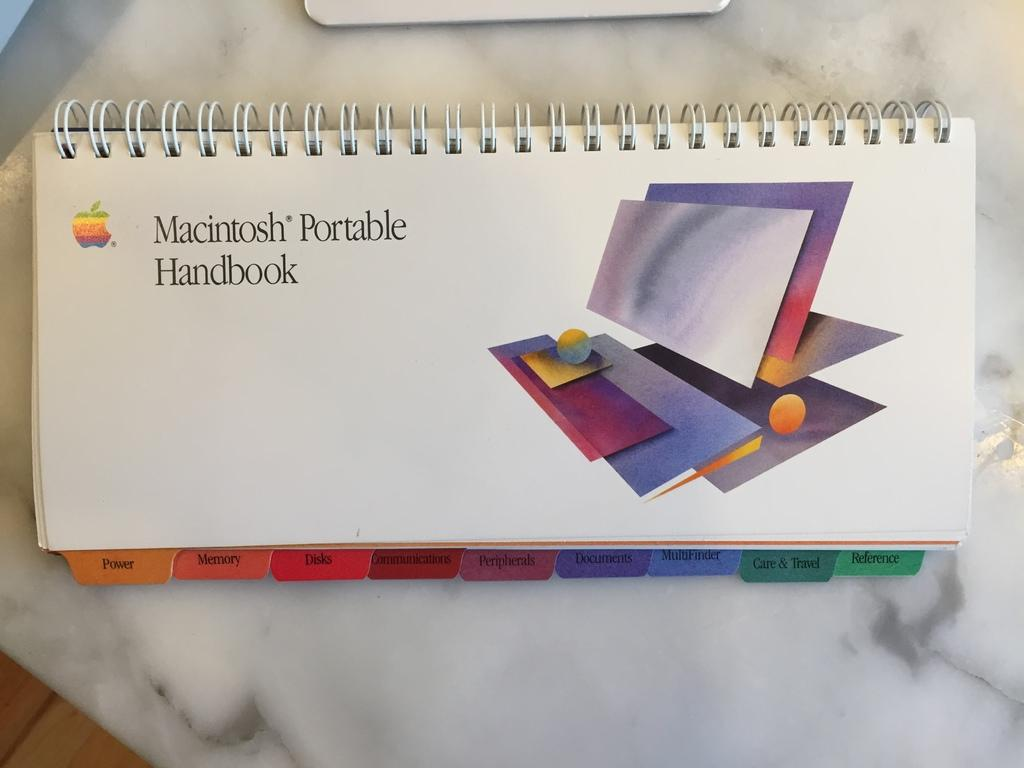Provide a one-sentence caption for the provided image. A spiral bound handbook for the Macintosh Portable product. 